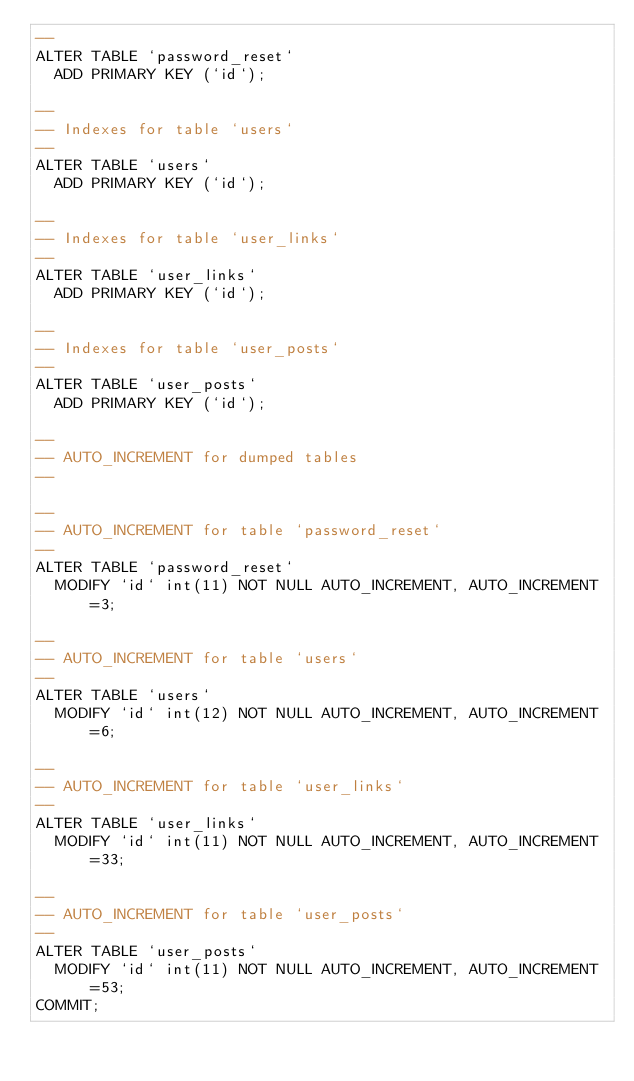<code> <loc_0><loc_0><loc_500><loc_500><_SQL_>--
ALTER TABLE `password_reset`
  ADD PRIMARY KEY (`id`);

--
-- Indexes for table `users`
--
ALTER TABLE `users`
  ADD PRIMARY KEY (`id`);

--
-- Indexes for table `user_links`
--
ALTER TABLE `user_links`
  ADD PRIMARY KEY (`id`);

--
-- Indexes for table `user_posts`
--
ALTER TABLE `user_posts`
  ADD PRIMARY KEY (`id`);

--
-- AUTO_INCREMENT for dumped tables
--

--
-- AUTO_INCREMENT for table `password_reset`
--
ALTER TABLE `password_reset`
  MODIFY `id` int(11) NOT NULL AUTO_INCREMENT, AUTO_INCREMENT=3;

--
-- AUTO_INCREMENT for table `users`
--
ALTER TABLE `users`
  MODIFY `id` int(12) NOT NULL AUTO_INCREMENT, AUTO_INCREMENT=6;

--
-- AUTO_INCREMENT for table `user_links`
--
ALTER TABLE `user_links`
  MODIFY `id` int(11) NOT NULL AUTO_INCREMENT, AUTO_INCREMENT=33;

--
-- AUTO_INCREMENT for table `user_posts`
--
ALTER TABLE `user_posts`
  MODIFY `id` int(11) NOT NULL AUTO_INCREMENT, AUTO_INCREMENT=53;
COMMIT;
</code> 